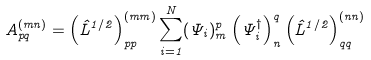<formula> <loc_0><loc_0><loc_500><loc_500>A ^ { ( m n ) } _ { p q } = \left ( \hat { L } ^ { 1 / 2 } \right ) ^ { ( m m ) } _ { p p } \sum _ { i = 1 } ^ { N } ( \Psi _ { i } ) ^ { p } _ { m } \left ( \Psi _ { i } ^ { \dagger } \right ) ^ { q } _ { n } \left ( \hat { L } ^ { 1 / 2 } \right ) ^ { ( n n ) } _ { q q }</formula> 